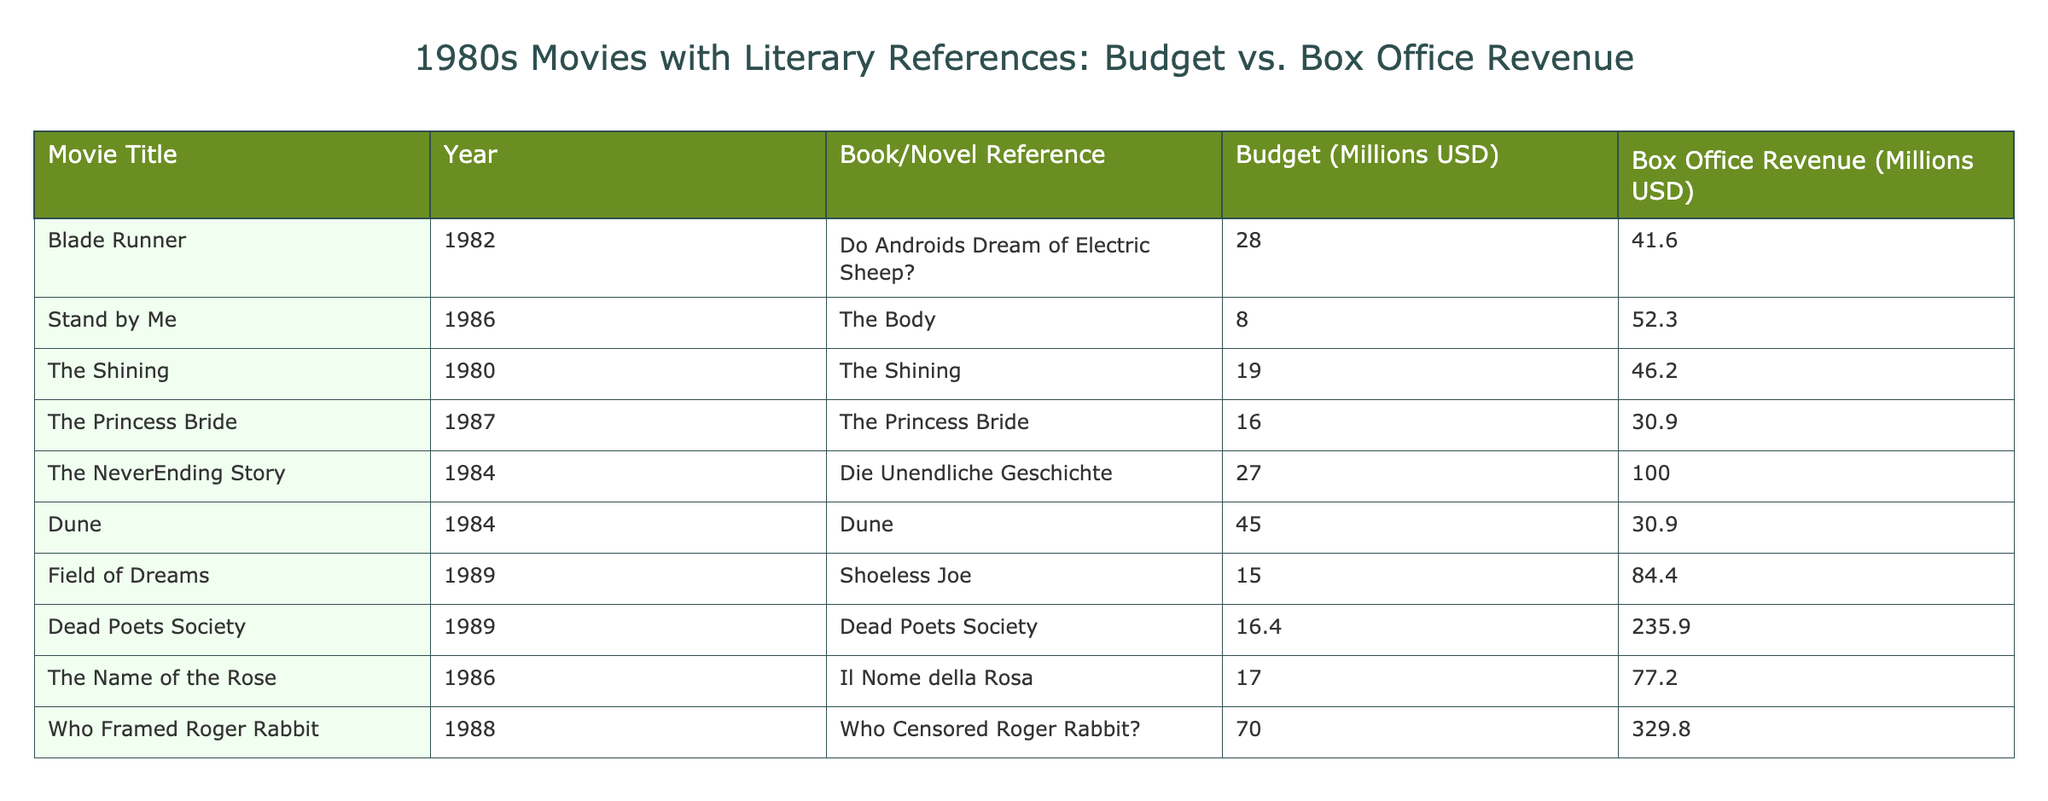What is the budget for "Who Framed Roger Rabbit"? The budget column of the table shows the values for each movie. For "Who Framed Roger Rabbit", the budget is listed as 70 million USD.
Answer: 70 million USD Which movie had the highest box office revenue? By examining the box office revenue column, "Who Framed Roger Rabbit" has the highest value at 329.8 million USD.
Answer: 329.8 million USD What is the average budget of all movies listed in the table? To find the average budget, sum the budgets: (28 + 8 + 19 + 16 + 27 + 45 + 15 + 16.4 + 17 + 70) =  251.4 million USD. Divide by the number of movies (10) gives 251.4 / 10 = 25.14 million USD.
Answer: 25.14 million USD Did "Stand by Me" earn more than its budget? Checking the table, the budget for "Stand by Me" is 8 million USD and the box office revenue is 52.3 million USD. Since 52.3 million is more than 8 million, the answer is yes.
Answer: Yes Which movie had the lowest budget, and what was its box office revenue? Examining the budget column, "Stand by Me" has the lowest budget at 8 million USD. Its corresponding box office revenue from the table is 52.3 million USD.
Answer: 8 million USD, 52.3 million USD What is the total box office revenue from the movies based on literary works? Adding all the box office revenues from the table gives: (41.6 + 52.3 + 46.2 + 30.9 + 100 + 30.9 + 84.4 + 235.9 + 77.2 + 329.8) =  1,400.2 million USD.
Answer: 1,400.2 million USD If we remove the movie with the highest budget, what is the new average box office revenue of the remaining films? The highest budget is for "Dune" at 45 million USD, so we will remove that film's box office revenue (30.9 million USD). The remaining total box office (1,400.2 - 30.9) = 1,369.3 million USD from 9 movies gives an average of 1,369.3 / 9 = 152.2 million USD.
Answer: 152.2 million USD How many movies had a box office revenue greater than 50 million USD? The box office revenues are checked one by one for each movie: "Blade Runner", "Stand by Me", "The Shining", "The NeverEnding Story", "Field of Dreams", "Dead Poets Society", "The Name of the Rose", and "Who Framed Roger Rabbit" all exceed 50 million USD. This totals to 8 movies.
Answer: 8 movies What percentage of the total box office revenue was made by "Dead Poets Society"? "Dead Poets Society" earned 235.9 million USD. To find the percentage, divide this revenue by the total box office (1,400.2 million USD) and multiply by 100: (235.9 / 1,400.2) * 100 ≈ 16.84%.
Answer: 16.84% 